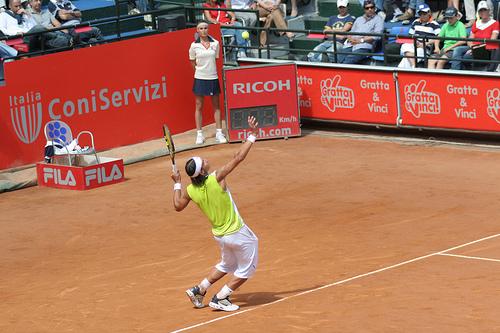What country is hosting this tennis match?
Keep it brief. Italy. What type of ground is the man playing tennis on?
Short answer required. Clay. Is the man in motion?
Quick response, please. Yes. 